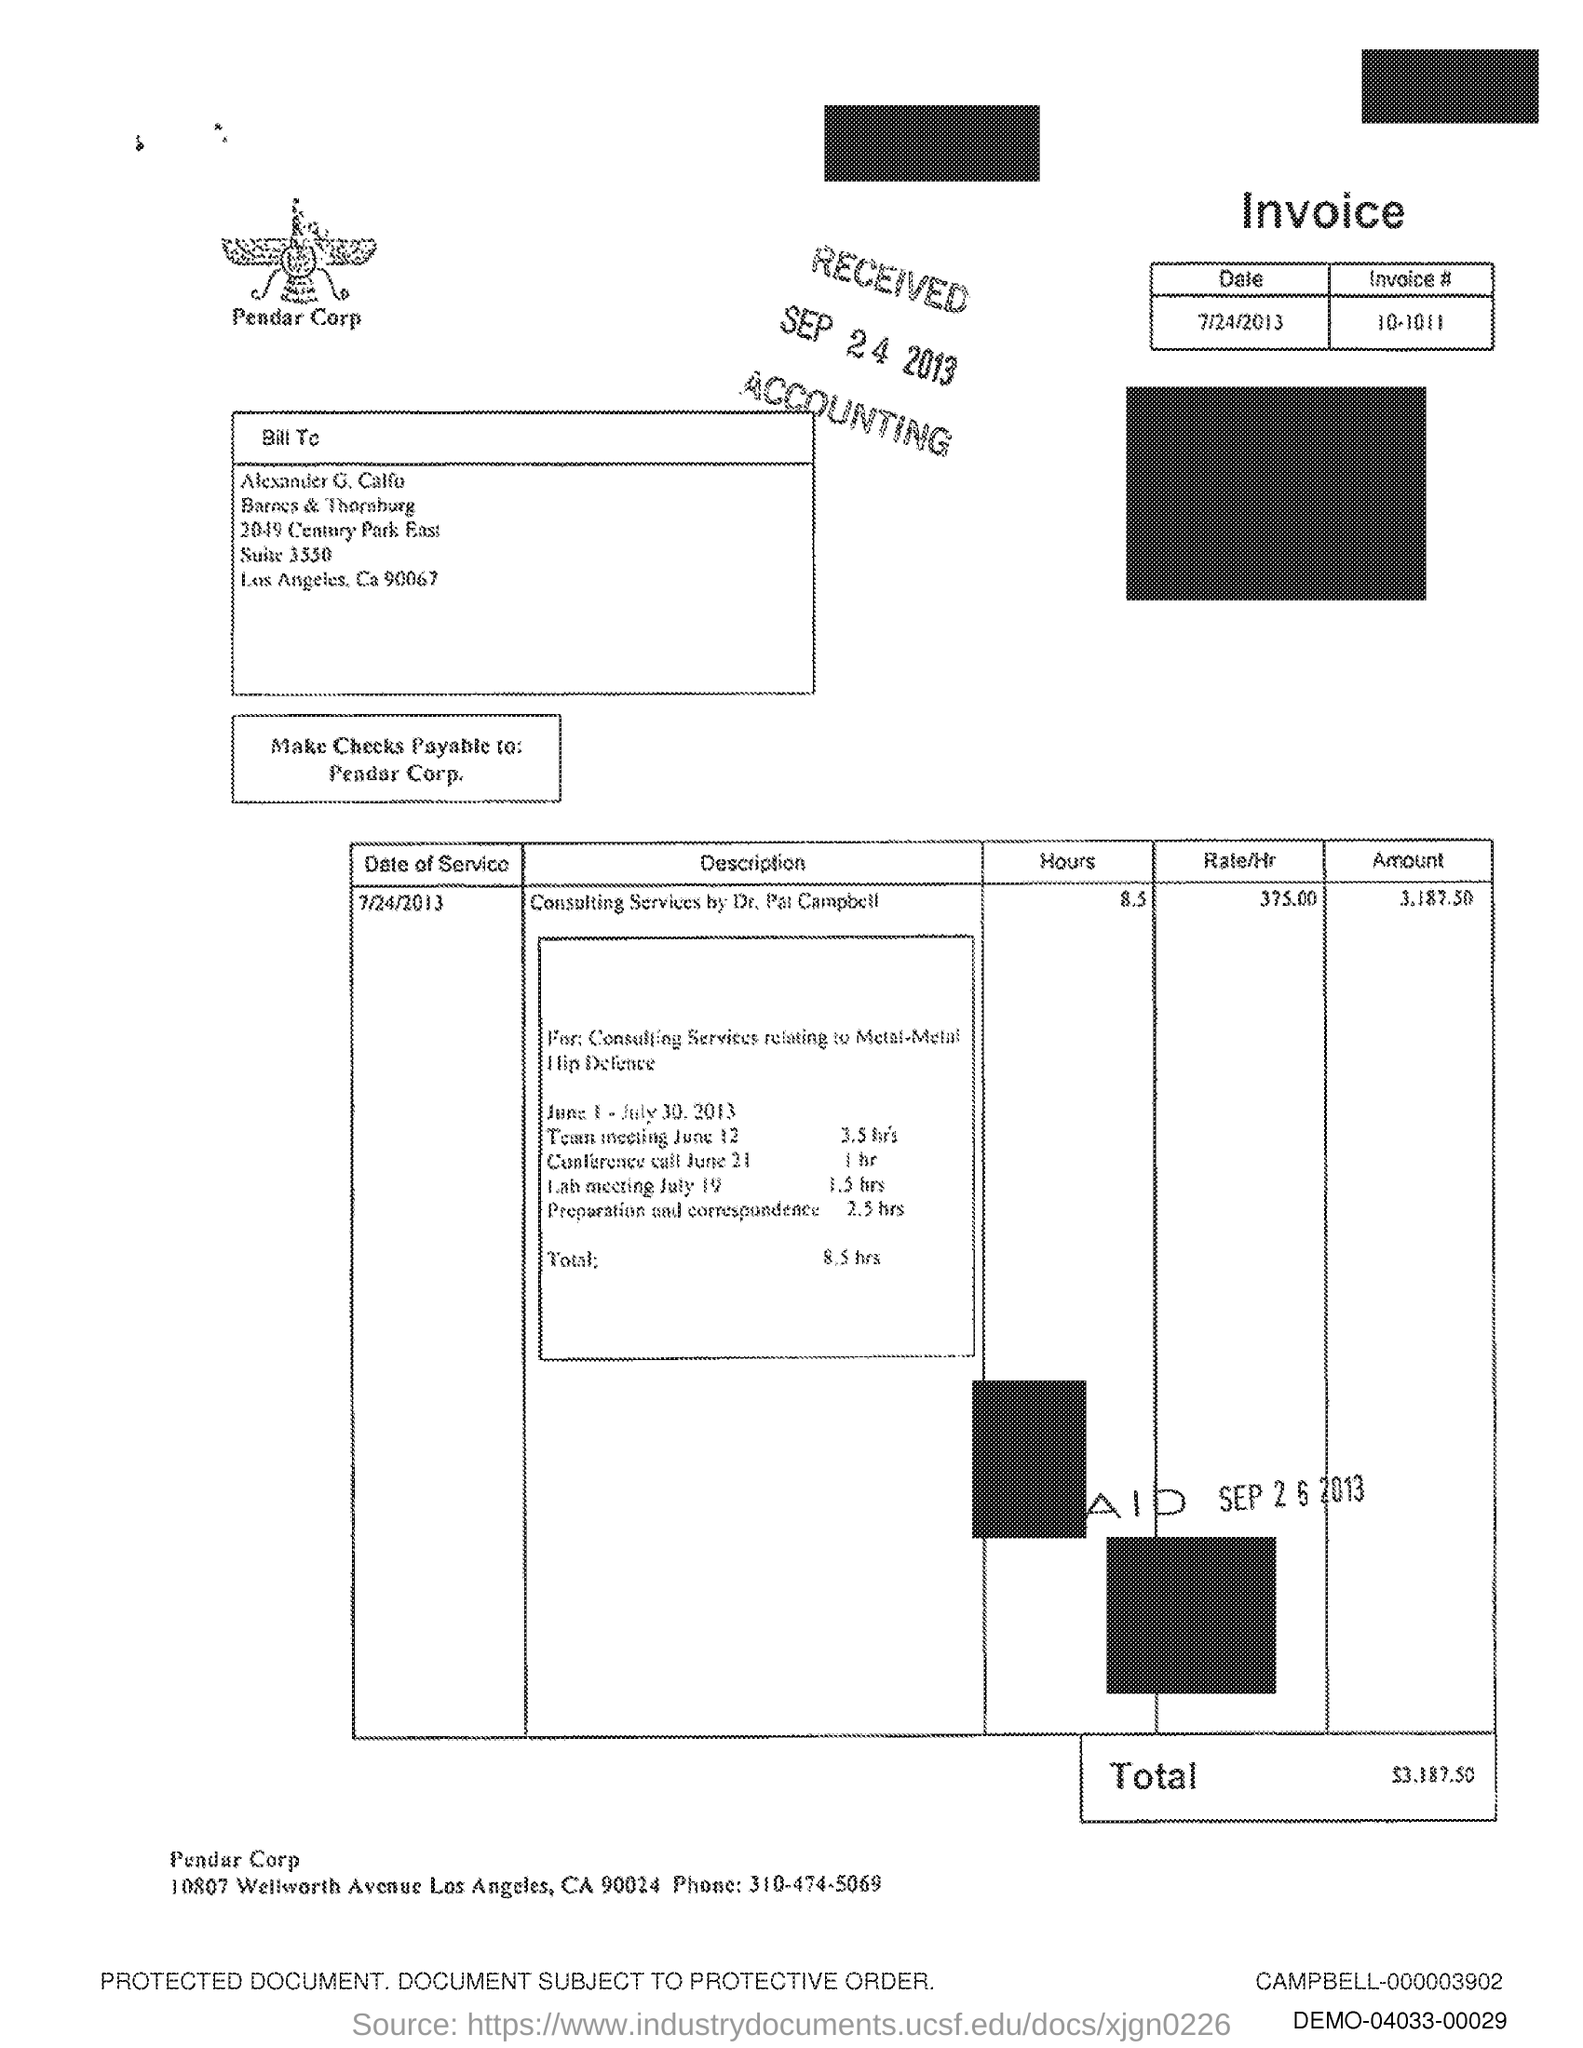What is the text written below the image?
Your answer should be very brief. Pendar Corp. What is the Phone number?
Make the answer very short. 310-474-5069. 